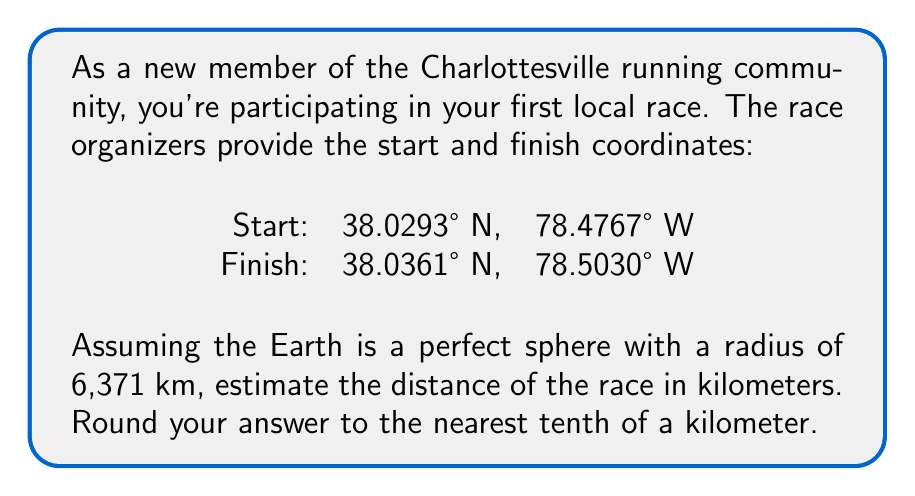Provide a solution to this math problem. To solve this problem, we'll use the Haversine formula, which calculates the great-circle distance between two points on a sphere given their latitude and longitude coordinates.

Step 1: Convert the coordinates from degrees to radians.
$$\text{lat}_1 = 38.0293° \times \frac{\pi}{180} = 0.6636 \text{ rad}$$
$$\text{lon}_1 = -78.4767° \times \frac{\pi}{180} = -1.3698 \text{ rad}$$
$$\text{lat}_2 = 38.0361° \times \frac{\pi}{180} = 0.6637 \text{ rad}$$
$$\text{lon}_2 = -78.5030° \times \frac{\pi}{180} = -1.3703 \text{ rad}$$

Step 2: Calculate the differences in latitude and longitude.
$$\Delta\text{lat} = \text{lat}_2 - \text{lat}_1 = 0.0001 \text{ rad}$$
$$\Delta\text{lon} = \text{lon}_2 - \text{lon}_1 = -0.0005 \text{ rad}$$

Step 3: Apply the Haversine formula.
$$a = \sin^2(\frac{\Delta\text{lat}}{2}) + \cos(\text{lat}_1) \cos(\text{lat}_2) \sin^2(\frac{\Delta\text{lon}}{2})$$
$$c = 2 \times \arctan2(\sqrt{a}, \sqrt{1-a})$$
$$d = R \times c$$

Where $R$ is the Earth's radius (6,371 km).

Step 4: Calculate the values.
$$a = \sin^2(0.00005) + \cos(0.6636) \cos(0.6637) \sin^2(-0.00025) = 1.0625 \times 10^{-7}$$
$$c = 2 \times \arctan2(\sqrt{1.0625 \times 10^{-7}}, \sqrt{1 - 1.0625 \times 10^{-7}}) = 0.0004605$$
$$d = 6371 \times 0.0004605 = 2.9338 \text{ km}$$

Step 5: Round to the nearest tenth of a kilometer.
$$2.9338 \text{ km} \approx 2.9 \text{ km}$$
Answer: The estimated distance of the race is 2.9 km. 